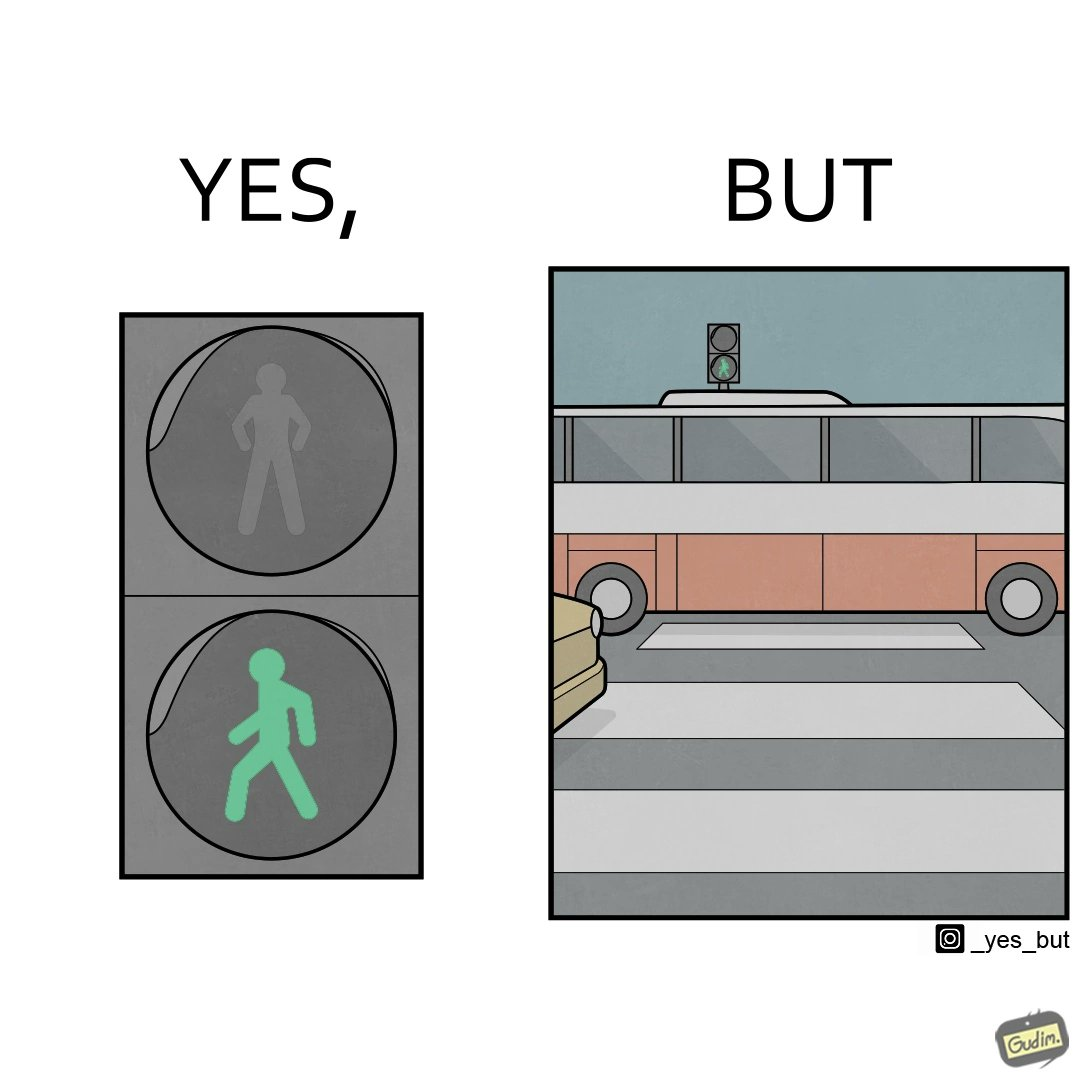Compare the left and right sides of this image. In the left part of the image: a traffic signal for the pedestrians and the signal is green, so pedestrians can cross the road In the right part of the image: a bus standing on the zebra crossing, while the traffic signal is green for the pedestrians symbolising  they can cross the road now 